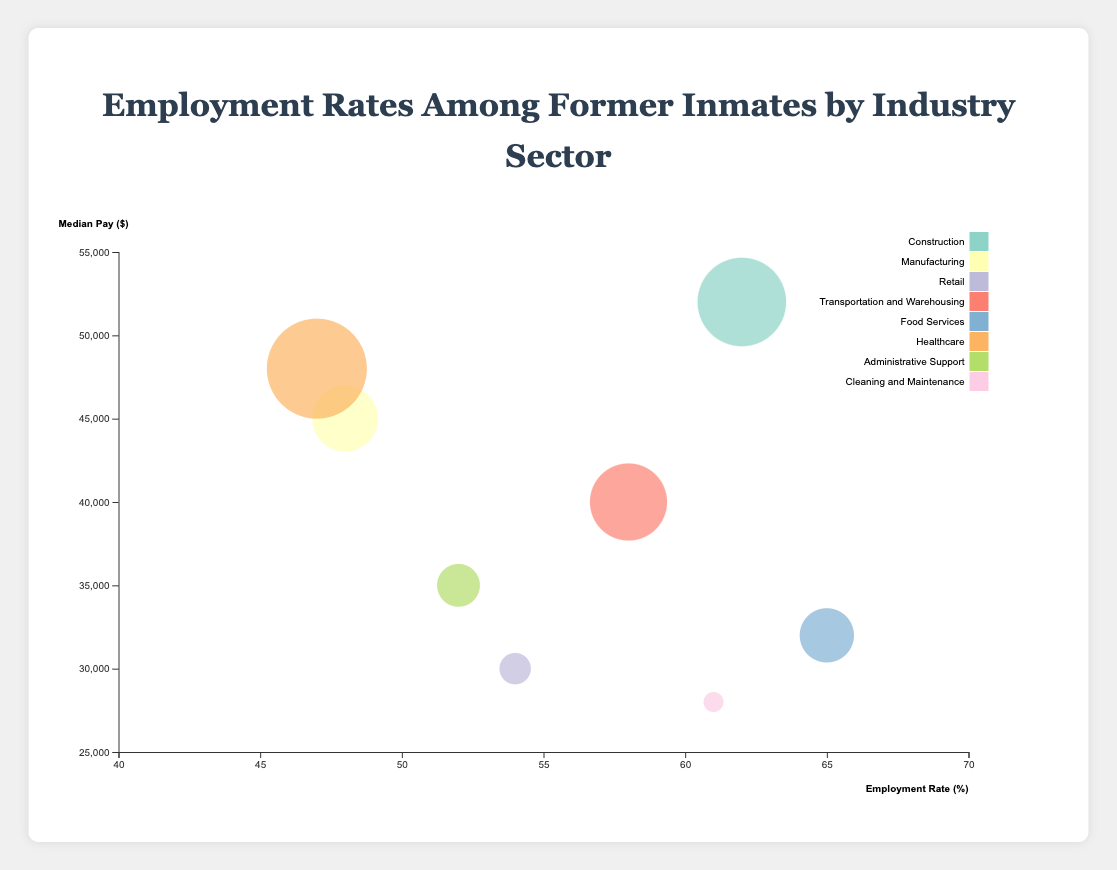What is the title of the chart? The title of the chart is typically displayed at the top, making it straightforward to identify. In this case, it's written at the top center in large, distinct text.
Answer: Employment Rates Among Former Inmates by Industry Sector Which industry has the highest employment rate? To find the highest employment rate, look at the x-axis (Employment Rate) and identify the bubble farthest to the right. The bubble representing Food Services is at 65%, the highest among all sectors.
Answer: Food Services How does the employment rate in Healthcare compare to Administrative Support? Locate the bubbles for Healthcare and Administrative Support on the x-axis. Healthcare is at 47%, and Administrative Support is at 52%. A simple comparison shows that Administrative Support has a higher employment rate.
Answer: Healthcare (47%) < Administrative Support (52%) Which company offers the highest median pay? Examine the y-axis (Median Pay) and identify the bubble positioned highest. The Construction industry bubble, associated with Skanska, is at the highest point on the y-axis, representing the highest median pay of $52,000.
Answer: Skanska What are the approximate employment rates and median pays in the Construction and Manufacturing sectors? Locate the Construction and Manufacturing bubbles. Construction is at 62% employment rate and $52,000 median pay, while Manufacturing is at 48% employment rate and $45,000 median pay. Compare these values to see differences and similarities.
Answer: Construction: 62%, $52,000; Manufacturing: 48%, $45,000 Which industry has the largest bubble size and what does it represent? The largest bubble represents the highest value in BubbleSizeMetric. The Healthcare sector bubble is the largest, meaning it tops the BubbleSizeMetric values with 310.
Answer: Healthcare What is the median pay difference between Transportation and Warehousing and Food Services? Check the y-axis positions for these industries. Transportation and Warehousing has a median pay of $40,000, while Food Services offers $32,000. Subtract the smaller pay from the larger to find the difference: $40,000 - $32,000 = $8,000.
Answer: $8,000 Which sector has the smallest bubble, and what information does it represent? Look for the smallest bubble in size. The Cleaning and Maintenance bubble is the smallest with 240 for the BubbleSizeMetric, representing that sector.
Answer: Cleaning and Maintenance What's the range of employment rates among these sectors? Identify the minimum and maximum employment rate values on the x-axis: Healthcare at 47% is the minimum, and Food Services at 65% is the maximum. Subtract to obtain the range: 65% - 47% = 18%.
Answer: 18% Compare the median pays of the Retail and Administrative Support sectors. Locate their y-axis positions: Retail's median pay is $30,000, and Administrative Support's median pay is $35,000. Retail's median pay is $5,000 less than Administrative Support's.
Answer: Retail: $30,000 < Administrative Support: $35,000 